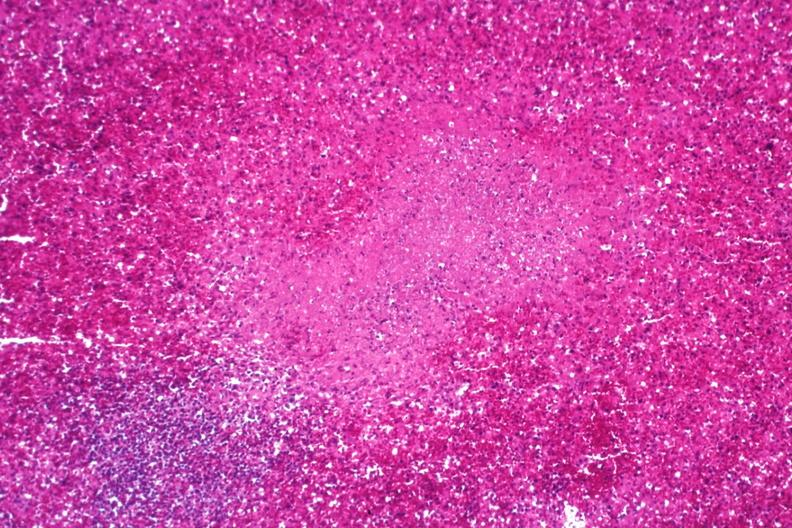does bilateral cleft palate show necrotizing granuloma?
Answer the question using a single word or phrase. No 